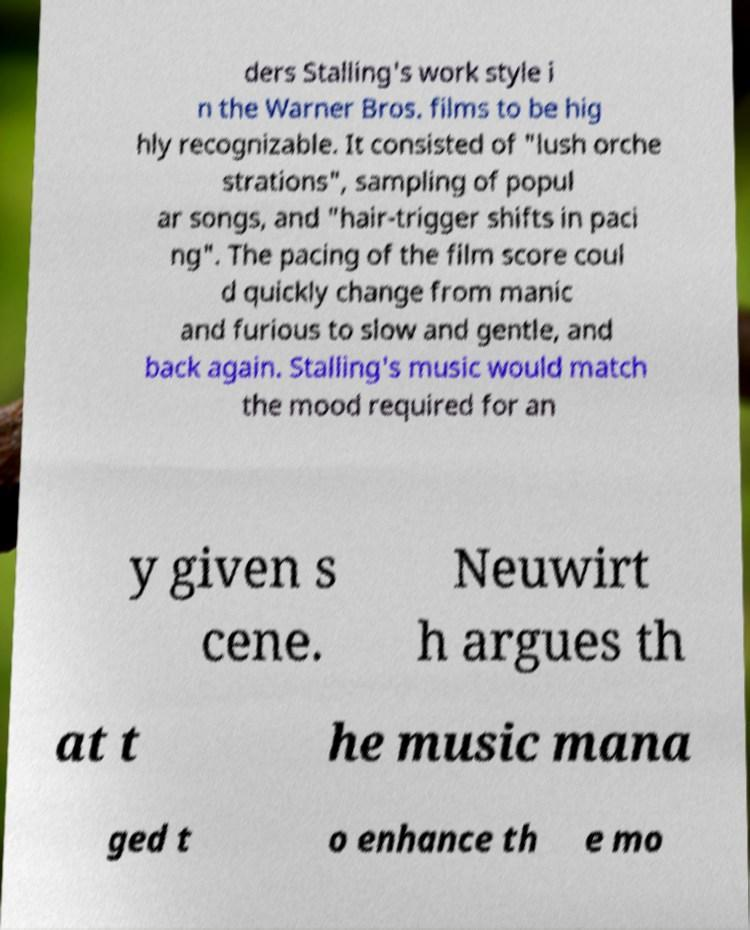Could you extract and type out the text from this image? ders Stalling's work style i n the Warner Bros. films to be hig hly recognizable. It consisted of "lush orche strations", sampling of popul ar songs, and "hair-trigger shifts in paci ng". The pacing of the film score coul d quickly change from manic and furious to slow and gentle, and back again. Stalling's music would match the mood required for an y given s cene. Neuwirt h argues th at t he music mana ged t o enhance th e mo 